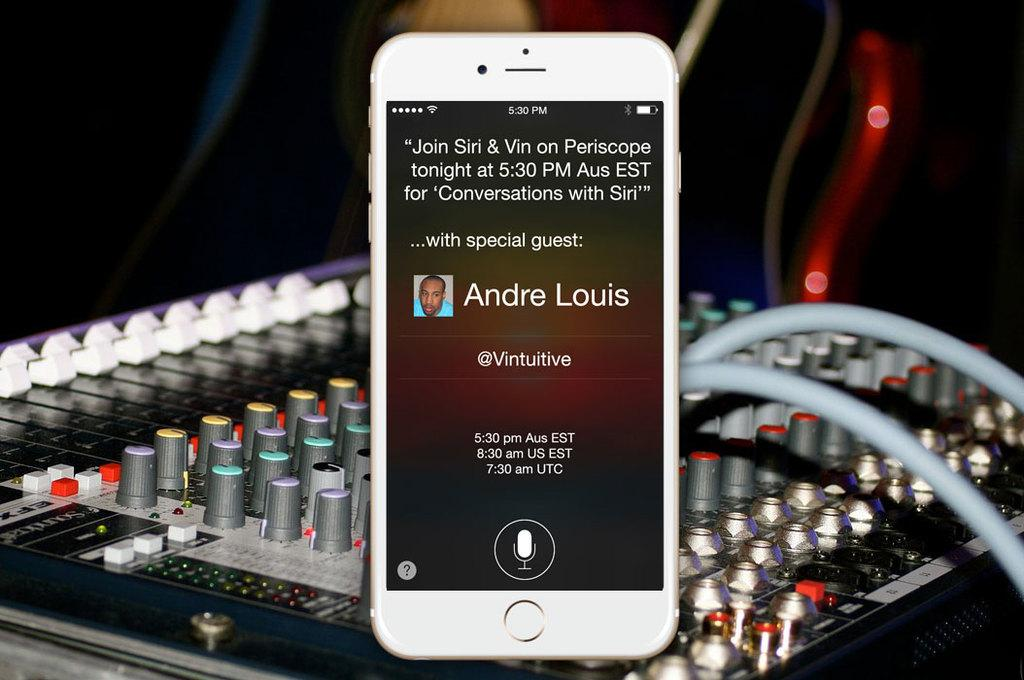<image>
Write a terse but informative summary of the picture. a phone with the name of Andre Louis on it 